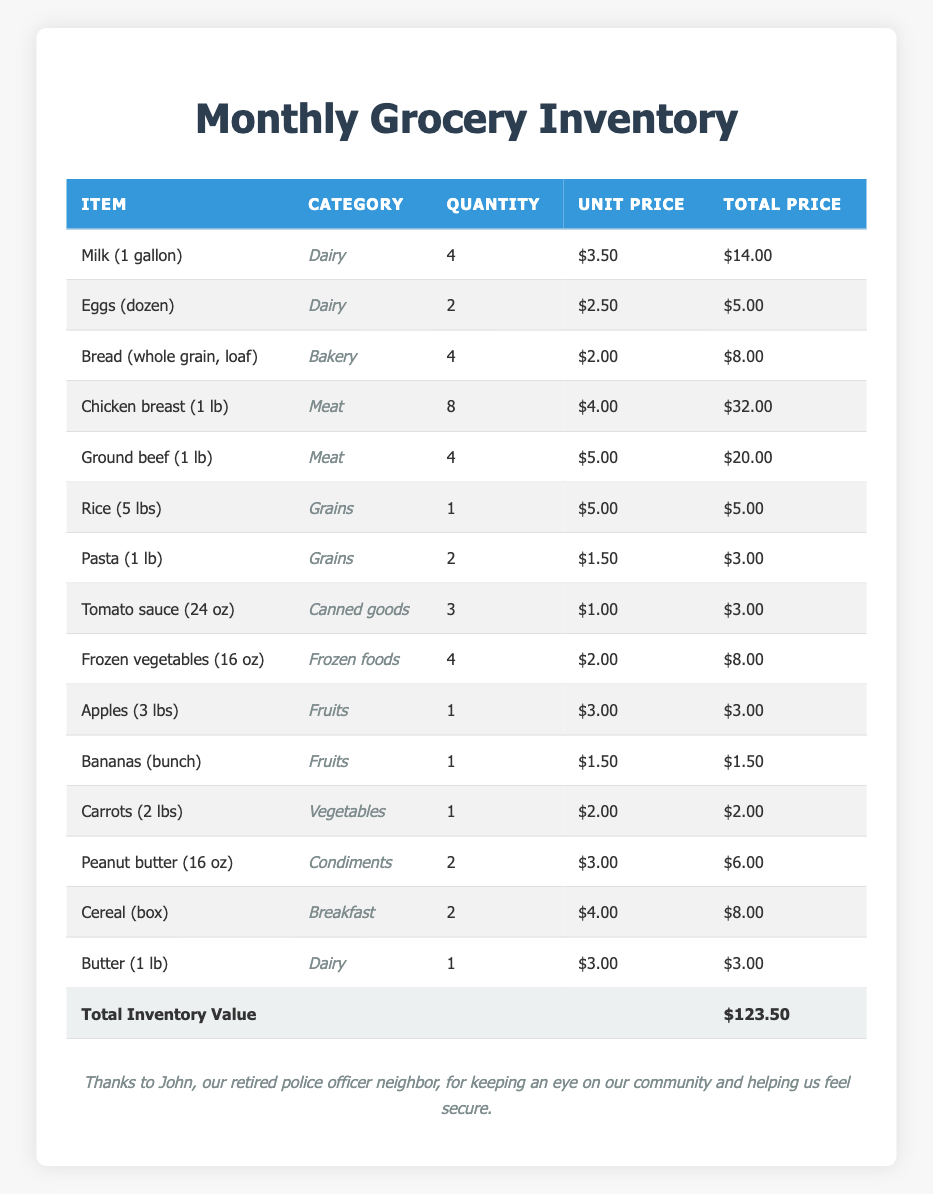What is the total price of the Chicken breast? The Chicken breast has a unit price of $4.00 and a quantity of 8. To find the total price, multiply the unit price by the quantity: 4.00 * 8 = $32.00
Answer: $32.00 How many loaves of Bread are in the inventory? The table lists 4 loaves of Bread (whole grain) in the inventory.
Answer: 4 What is the total inventory value? The total inventory value is explicitly stated at the bottom of the inventory table as $123.50.
Answer: $123.50 Which category has the most items listed? The Meat category has two items listed: Chicken breast and Ground beef, while Dairy also has three items. Therefore, Dairy has the most items compared to others.
Answer: Dairy What is the average price of the items in the Grains category? The Grains category has two items: Rice (5 lbs) costing $5.00 and Pasta (1 lb) costing $3.00. To find the average, sum the total prices (5 + 3 = 8) and divide by the number of items (2): 8/2 = 4.00.
Answer: $4.00 Is there a higher quantity of Frozen vegetables than Fruits? There are 4 quantities of Frozen vegetables and 2 quantities of Fruits (apples and bananas). Since 4 is greater than 2, the statement is true.
Answer: Yes What would be the total cost if we bought double the quantity of Eggs? There are currently 2 dozen of Eggs at $2.50 each. If we buy double, the quantity will be 4 dozen. The total would then be 4 * 2.50 = $10.00.
Answer: $10.00 If we want to buy all items listed in the Dairy category, what is the total cost? The Dairy category includes Milk ($14.00), Eggs ($5.00), and Butter ($3.00). Adding these costs gives us: 14 + 5 + 3 = 22.
Answer: $22.00 How many items in the inventory are classified as Vegetables? There is only 1 item classified as Vegetables, which is Carrots (2 lbs).
Answer: 1 